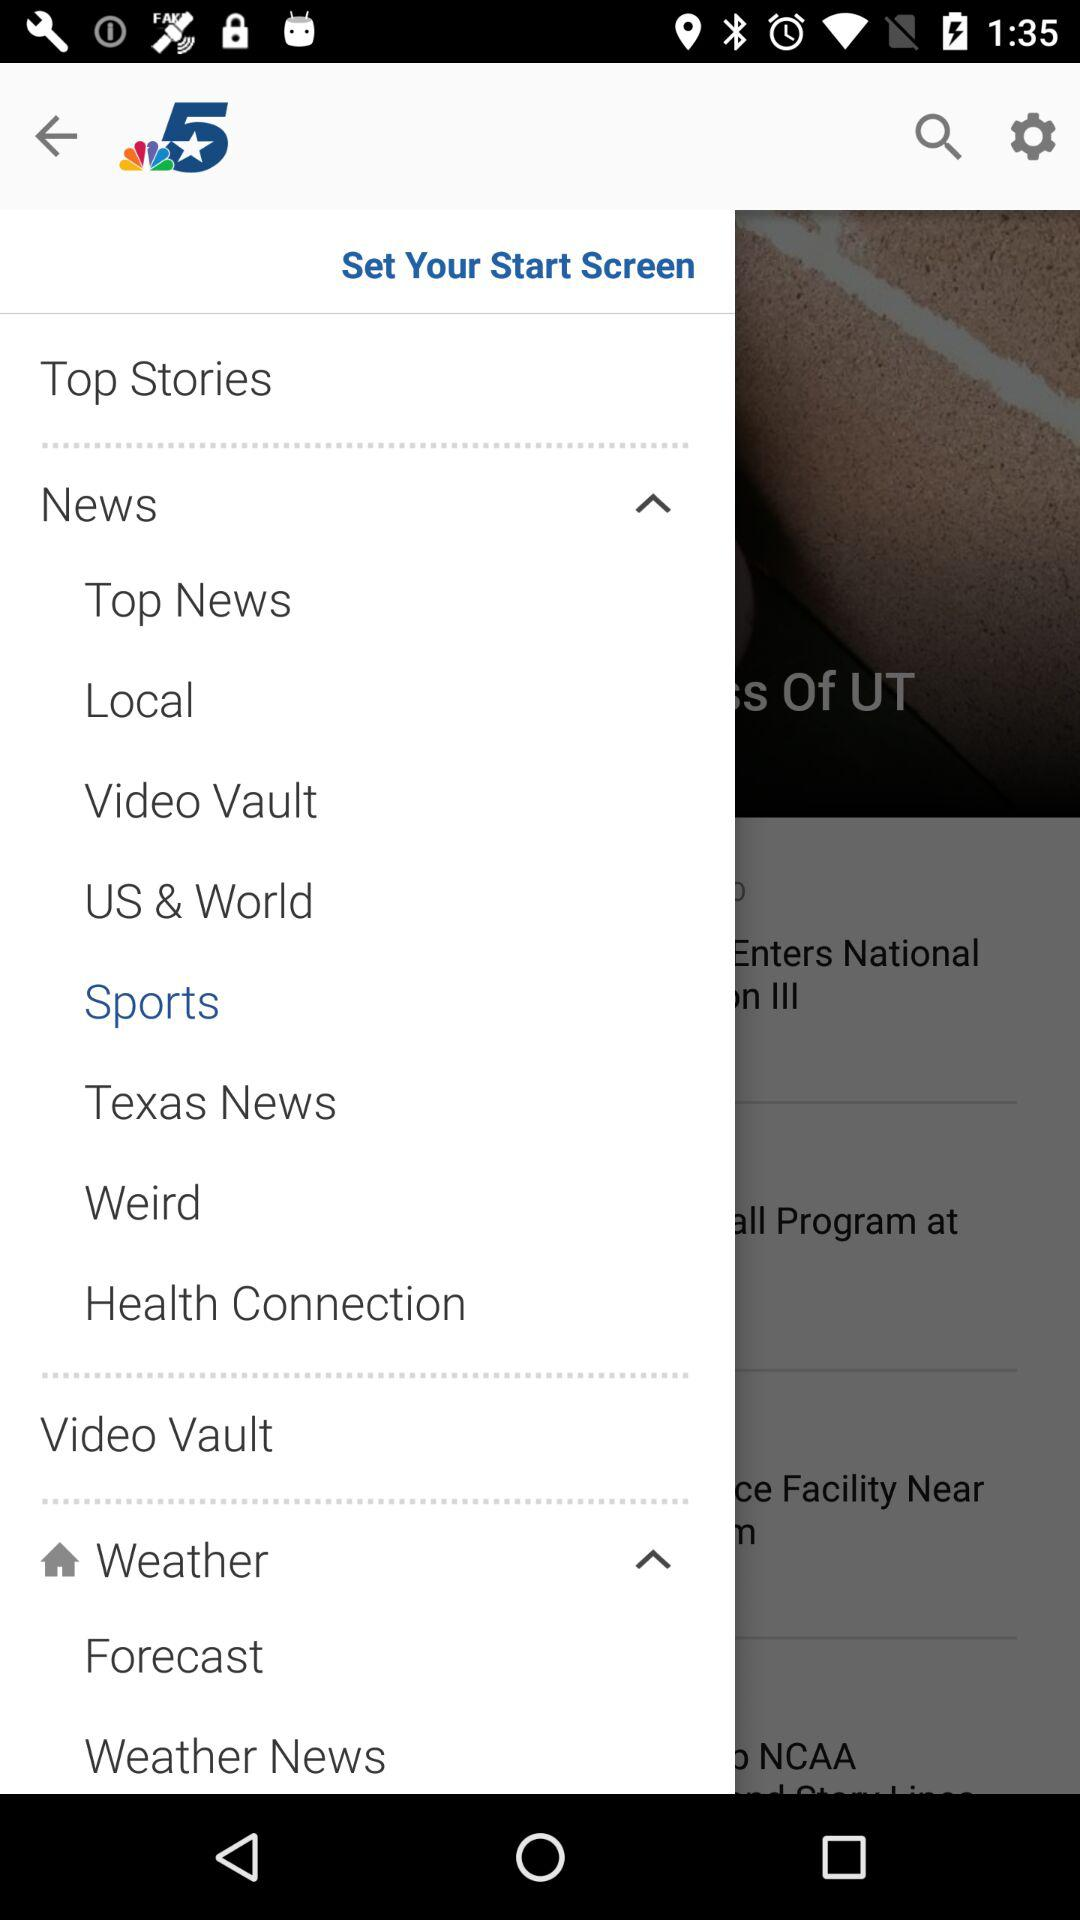What is the application name? The application name is "NBC 5 Dallas-Fort Worth News". 